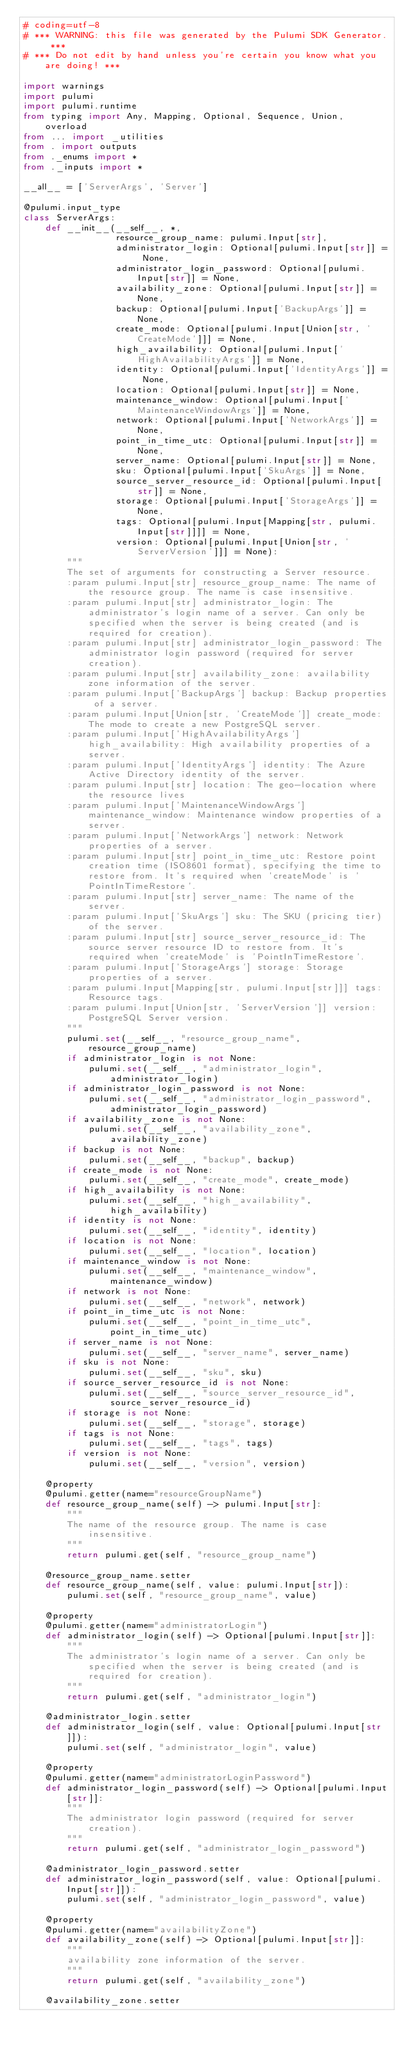<code> <loc_0><loc_0><loc_500><loc_500><_Python_># coding=utf-8
# *** WARNING: this file was generated by the Pulumi SDK Generator. ***
# *** Do not edit by hand unless you're certain you know what you are doing! ***

import warnings
import pulumi
import pulumi.runtime
from typing import Any, Mapping, Optional, Sequence, Union, overload
from ... import _utilities
from . import outputs
from ._enums import *
from ._inputs import *

__all__ = ['ServerArgs', 'Server']

@pulumi.input_type
class ServerArgs:
    def __init__(__self__, *,
                 resource_group_name: pulumi.Input[str],
                 administrator_login: Optional[pulumi.Input[str]] = None,
                 administrator_login_password: Optional[pulumi.Input[str]] = None,
                 availability_zone: Optional[pulumi.Input[str]] = None,
                 backup: Optional[pulumi.Input['BackupArgs']] = None,
                 create_mode: Optional[pulumi.Input[Union[str, 'CreateMode']]] = None,
                 high_availability: Optional[pulumi.Input['HighAvailabilityArgs']] = None,
                 identity: Optional[pulumi.Input['IdentityArgs']] = None,
                 location: Optional[pulumi.Input[str]] = None,
                 maintenance_window: Optional[pulumi.Input['MaintenanceWindowArgs']] = None,
                 network: Optional[pulumi.Input['NetworkArgs']] = None,
                 point_in_time_utc: Optional[pulumi.Input[str]] = None,
                 server_name: Optional[pulumi.Input[str]] = None,
                 sku: Optional[pulumi.Input['SkuArgs']] = None,
                 source_server_resource_id: Optional[pulumi.Input[str]] = None,
                 storage: Optional[pulumi.Input['StorageArgs']] = None,
                 tags: Optional[pulumi.Input[Mapping[str, pulumi.Input[str]]]] = None,
                 version: Optional[pulumi.Input[Union[str, 'ServerVersion']]] = None):
        """
        The set of arguments for constructing a Server resource.
        :param pulumi.Input[str] resource_group_name: The name of the resource group. The name is case insensitive.
        :param pulumi.Input[str] administrator_login: The administrator's login name of a server. Can only be specified when the server is being created (and is required for creation).
        :param pulumi.Input[str] administrator_login_password: The administrator login password (required for server creation).
        :param pulumi.Input[str] availability_zone: availability zone information of the server.
        :param pulumi.Input['BackupArgs'] backup: Backup properties of a server.
        :param pulumi.Input[Union[str, 'CreateMode']] create_mode: The mode to create a new PostgreSQL server.
        :param pulumi.Input['HighAvailabilityArgs'] high_availability: High availability properties of a server.
        :param pulumi.Input['IdentityArgs'] identity: The Azure Active Directory identity of the server.
        :param pulumi.Input[str] location: The geo-location where the resource lives
        :param pulumi.Input['MaintenanceWindowArgs'] maintenance_window: Maintenance window properties of a server.
        :param pulumi.Input['NetworkArgs'] network: Network properties of a server.
        :param pulumi.Input[str] point_in_time_utc: Restore point creation time (ISO8601 format), specifying the time to restore from. It's required when 'createMode' is 'PointInTimeRestore'.
        :param pulumi.Input[str] server_name: The name of the server.
        :param pulumi.Input['SkuArgs'] sku: The SKU (pricing tier) of the server.
        :param pulumi.Input[str] source_server_resource_id: The source server resource ID to restore from. It's required when 'createMode' is 'PointInTimeRestore'.
        :param pulumi.Input['StorageArgs'] storage: Storage properties of a server.
        :param pulumi.Input[Mapping[str, pulumi.Input[str]]] tags: Resource tags.
        :param pulumi.Input[Union[str, 'ServerVersion']] version: PostgreSQL Server version.
        """
        pulumi.set(__self__, "resource_group_name", resource_group_name)
        if administrator_login is not None:
            pulumi.set(__self__, "administrator_login", administrator_login)
        if administrator_login_password is not None:
            pulumi.set(__self__, "administrator_login_password", administrator_login_password)
        if availability_zone is not None:
            pulumi.set(__self__, "availability_zone", availability_zone)
        if backup is not None:
            pulumi.set(__self__, "backup", backup)
        if create_mode is not None:
            pulumi.set(__self__, "create_mode", create_mode)
        if high_availability is not None:
            pulumi.set(__self__, "high_availability", high_availability)
        if identity is not None:
            pulumi.set(__self__, "identity", identity)
        if location is not None:
            pulumi.set(__self__, "location", location)
        if maintenance_window is not None:
            pulumi.set(__self__, "maintenance_window", maintenance_window)
        if network is not None:
            pulumi.set(__self__, "network", network)
        if point_in_time_utc is not None:
            pulumi.set(__self__, "point_in_time_utc", point_in_time_utc)
        if server_name is not None:
            pulumi.set(__self__, "server_name", server_name)
        if sku is not None:
            pulumi.set(__self__, "sku", sku)
        if source_server_resource_id is not None:
            pulumi.set(__self__, "source_server_resource_id", source_server_resource_id)
        if storage is not None:
            pulumi.set(__self__, "storage", storage)
        if tags is not None:
            pulumi.set(__self__, "tags", tags)
        if version is not None:
            pulumi.set(__self__, "version", version)

    @property
    @pulumi.getter(name="resourceGroupName")
    def resource_group_name(self) -> pulumi.Input[str]:
        """
        The name of the resource group. The name is case insensitive.
        """
        return pulumi.get(self, "resource_group_name")

    @resource_group_name.setter
    def resource_group_name(self, value: pulumi.Input[str]):
        pulumi.set(self, "resource_group_name", value)

    @property
    @pulumi.getter(name="administratorLogin")
    def administrator_login(self) -> Optional[pulumi.Input[str]]:
        """
        The administrator's login name of a server. Can only be specified when the server is being created (and is required for creation).
        """
        return pulumi.get(self, "administrator_login")

    @administrator_login.setter
    def administrator_login(self, value: Optional[pulumi.Input[str]]):
        pulumi.set(self, "administrator_login", value)

    @property
    @pulumi.getter(name="administratorLoginPassword")
    def administrator_login_password(self) -> Optional[pulumi.Input[str]]:
        """
        The administrator login password (required for server creation).
        """
        return pulumi.get(self, "administrator_login_password")

    @administrator_login_password.setter
    def administrator_login_password(self, value: Optional[pulumi.Input[str]]):
        pulumi.set(self, "administrator_login_password", value)

    @property
    @pulumi.getter(name="availabilityZone")
    def availability_zone(self) -> Optional[pulumi.Input[str]]:
        """
        availability zone information of the server.
        """
        return pulumi.get(self, "availability_zone")

    @availability_zone.setter</code> 